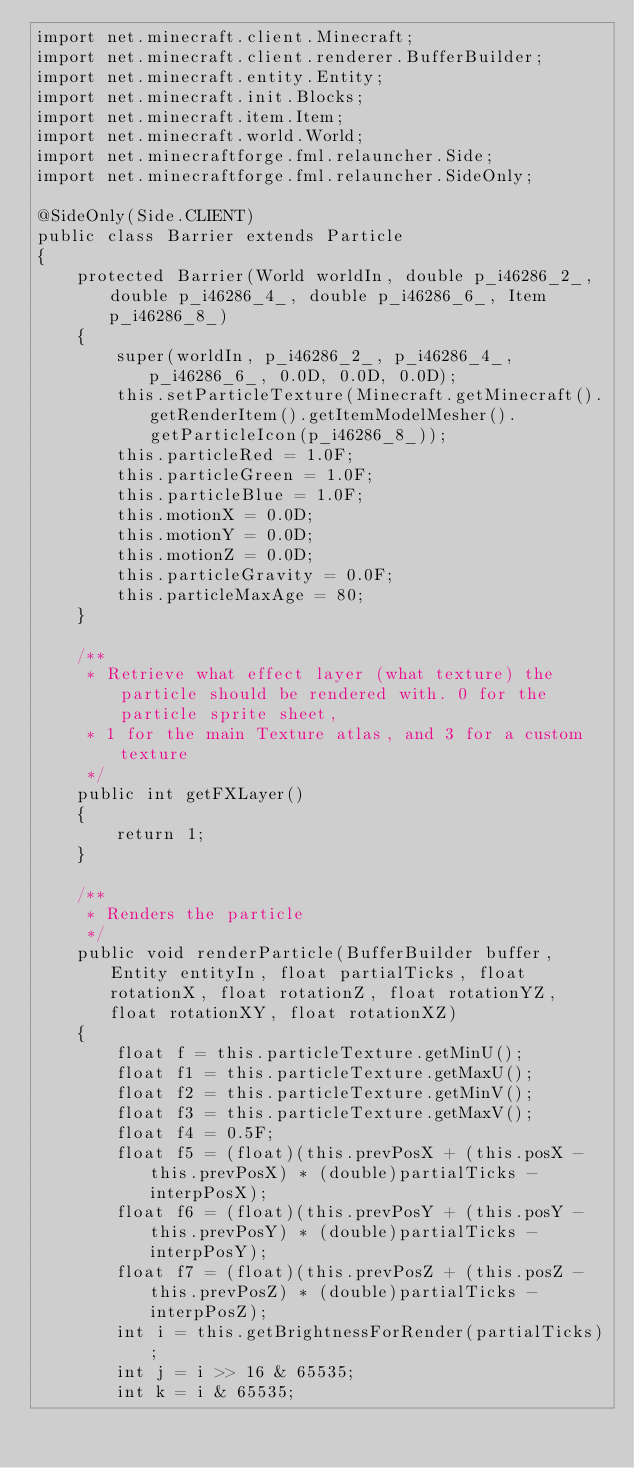Convert code to text. <code><loc_0><loc_0><loc_500><loc_500><_Java_>import net.minecraft.client.Minecraft;
import net.minecraft.client.renderer.BufferBuilder;
import net.minecraft.entity.Entity;
import net.minecraft.init.Blocks;
import net.minecraft.item.Item;
import net.minecraft.world.World;
import net.minecraftforge.fml.relauncher.Side;
import net.minecraftforge.fml.relauncher.SideOnly;

@SideOnly(Side.CLIENT)
public class Barrier extends Particle
{
    protected Barrier(World worldIn, double p_i46286_2_, double p_i46286_4_, double p_i46286_6_, Item p_i46286_8_)
    {
        super(worldIn, p_i46286_2_, p_i46286_4_, p_i46286_6_, 0.0D, 0.0D, 0.0D);
        this.setParticleTexture(Minecraft.getMinecraft().getRenderItem().getItemModelMesher().getParticleIcon(p_i46286_8_));
        this.particleRed = 1.0F;
        this.particleGreen = 1.0F;
        this.particleBlue = 1.0F;
        this.motionX = 0.0D;
        this.motionY = 0.0D;
        this.motionZ = 0.0D;
        this.particleGravity = 0.0F;
        this.particleMaxAge = 80;
    }

    /**
     * Retrieve what effect layer (what texture) the particle should be rendered with. 0 for the particle sprite sheet,
     * 1 for the main Texture atlas, and 3 for a custom texture
     */
    public int getFXLayer()
    {
        return 1;
    }

    /**
     * Renders the particle
     */
    public void renderParticle(BufferBuilder buffer, Entity entityIn, float partialTicks, float rotationX, float rotationZ, float rotationYZ, float rotationXY, float rotationXZ)
    {
        float f = this.particleTexture.getMinU();
        float f1 = this.particleTexture.getMaxU();
        float f2 = this.particleTexture.getMinV();
        float f3 = this.particleTexture.getMaxV();
        float f4 = 0.5F;
        float f5 = (float)(this.prevPosX + (this.posX - this.prevPosX) * (double)partialTicks - interpPosX);
        float f6 = (float)(this.prevPosY + (this.posY - this.prevPosY) * (double)partialTicks - interpPosY);
        float f7 = (float)(this.prevPosZ + (this.posZ - this.prevPosZ) * (double)partialTicks - interpPosZ);
        int i = this.getBrightnessForRender(partialTicks);
        int j = i >> 16 & 65535;
        int k = i & 65535;</code> 